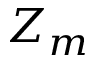Convert formula to latex. <formula><loc_0><loc_0><loc_500><loc_500>Z _ { m }</formula> 